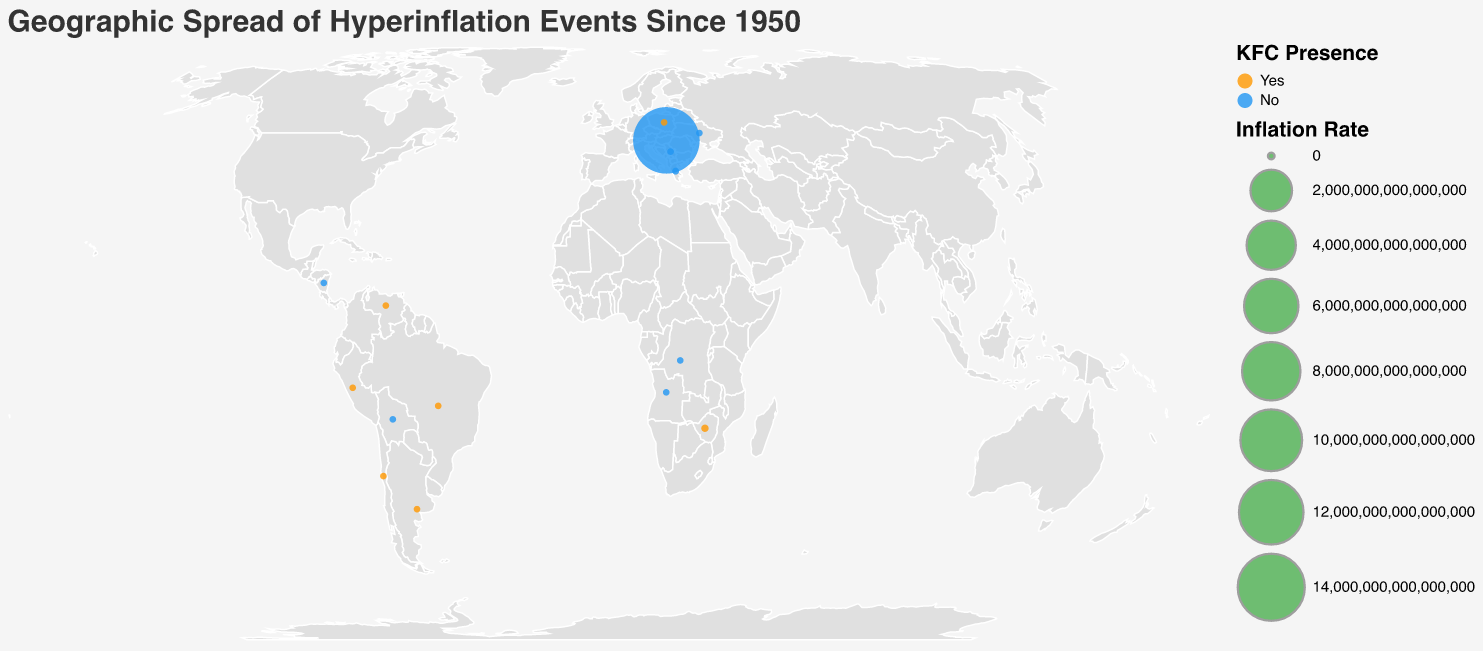Which country experienced the highest inflation rate? By observing the size of the circles, which represent the inflation rates, the largest circle is associated with Hungary. Checking the tooltip confirms that Hungary had an inflation rate of 13600000000000000 in 1946.
Answer: Hungary What is the title of the plot? The title is displayed at the top of the plot.
Answer: Geographic Spread of Hyperinflation Events Since 1950 How many countries displayed hyperinflation events where KFC was present? By analyzing the color legend and counting the number of orange circles (which represent the presence of KFC), there are 7 countries where KFC was present during hyperinflation events.
Answer: 7 Which country had a hyperinflation event in 2008? By examining the tooltips and checking the year, Zimbabwe had a hyperinflation event in 2008.
Answer: Zimbabwe Between Zimbabwe in 2008 and Venezuela in 2018, which had the lower inflation rate? Comparing the inflation rates of Zimbabwe in 2008 (79600000000) and Venezuela in 2018 (929790), Venezuela had a significantly lower inflation rate.
Answer: Venezuela Which country has a blue circle size second largest after Hungary's? By looking at the sizes of the blue circles (indicating no KFC presence) and referring to the tooltip data, Yugoslavia in 1994 has the second-largest blue circle after Hungary's.
Answer: Yugoslavia What is the inflation rate of Argentina in 1990? By locating Argentina's circle and viewing its tooltip, the inflation rate in 1990 was 20263.
Answer: 20263 Does Zimbabwe have a KFC presence during its hyperinflation event? By examining the circle color for Zimbabwe, it is orange, indicating that KFC was present.
Answer: Yes Which country had an event of hyperinflation earlier, Chile or Ukraine, and in which year? By checking the tooltips for the years of hyperinflation events, Chile experienced hyperinflation in 1973, and Ukraine in 1993. So, Chile's event happened earlier.
Answer: Chile in 1973 